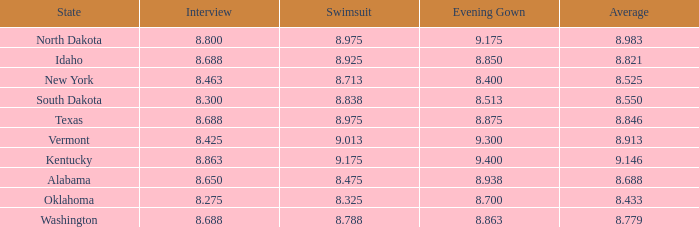What is the highest average of the contestant from Texas with an evening gown larger than 8.875? None. 